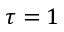<formula> <loc_0><loc_0><loc_500><loc_500>\tau = 1</formula> 